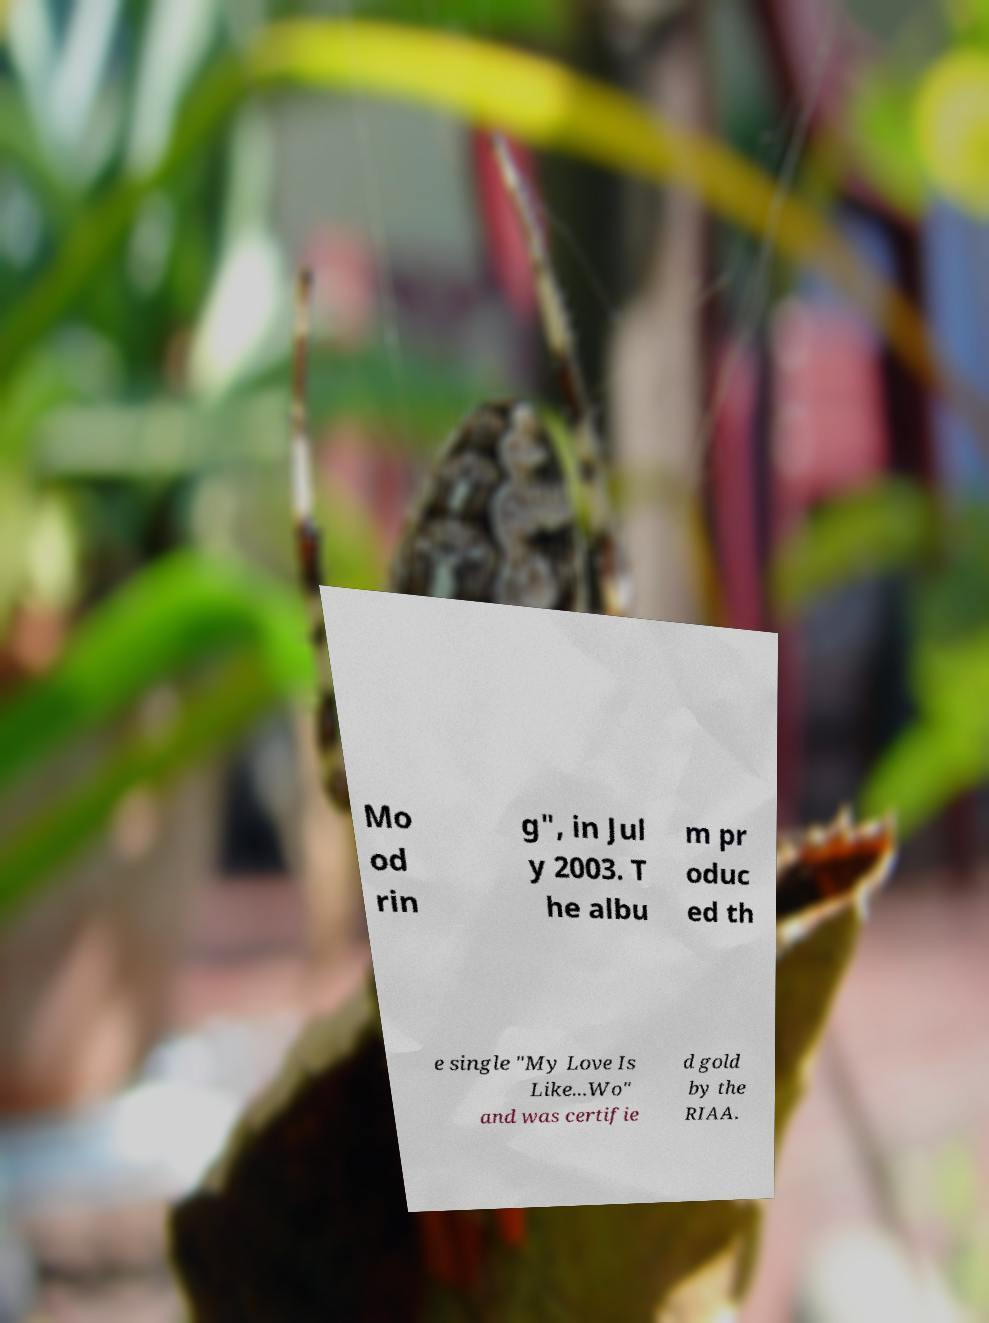Please identify and transcribe the text found in this image. Mo od rin g", in Jul y 2003. T he albu m pr oduc ed th e single "My Love Is Like...Wo" and was certifie d gold by the RIAA. 